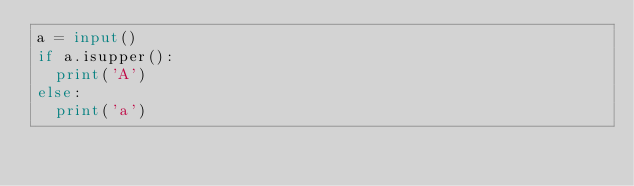Convert code to text. <code><loc_0><loc_0><loc_500><loc_500><_Python_>a = input()
if a.isupper():
  print('A')
else:
  print('a')</code> 